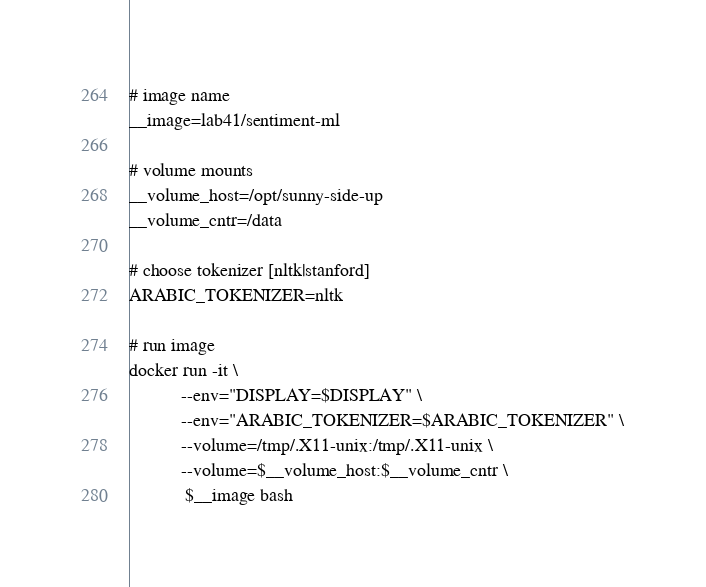Convert code to text. <code><loc_0><loc_0><loc_500><loc_500><_Bash_>
# image name
__image=lab41/sentiment-ml

# volume mounts
__volume_host=/opt/sunny-side-up
__volume_cntr=/data

# choose tokenizer [nltk|stanford]
ARABIC_TOKENIZER=nltk

# run image
docker run -it \
           --env="DISPLAY=$DISPLAY" \
           --env="ARABIC_TOKENIZER=$ARABIC_TOKENIZER" \
           --volume=/tmp/.X11-unix:/tmp/.X11-unix \
           --volume=$__volume_host:$__volume_cntr \
            $__image bash
</code> 